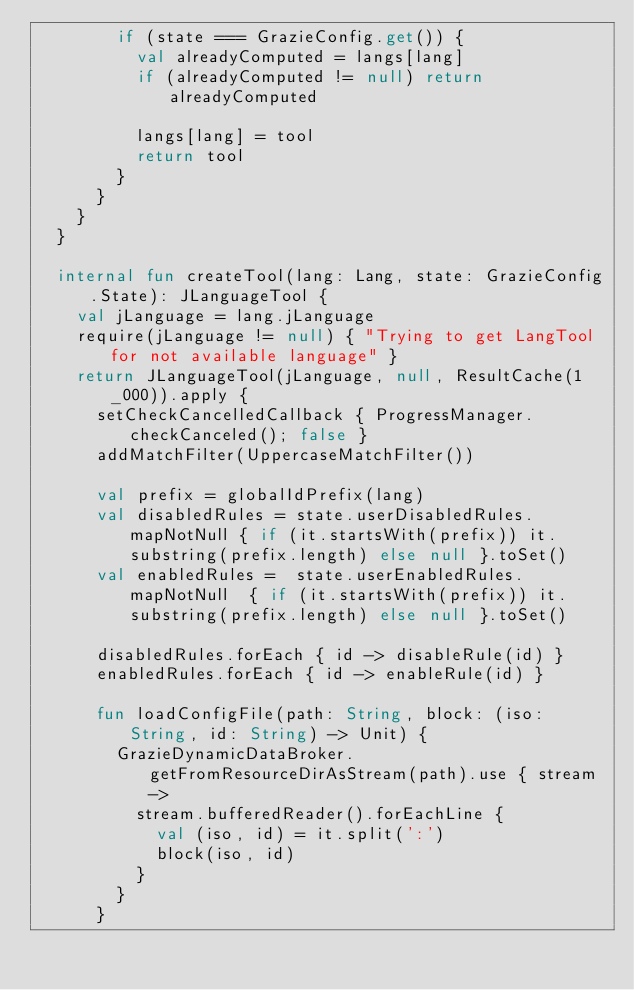Convert code to text. <code><loc_0><loc_0><loc_500><loc_500><_Kotlin_>        if (state === GrazieConfig.get()) {
          val alreadyComputed = langs[lang]
          if (alreadyComputed != null) return alreadyComputed

          langs[lang] = tool
          return tool
        }
      }
    }
  }

  internal fun createTool(lang: Lang, state: GrazieConfig.State): JLanguageTool {
    val jLanguage = lang.jLanguage
    require(jLanguage != null) { "Trying to get LangTool for not available language" }
    return JLanguageTool(jLanguage, null, ResultCache(1_000)).apply {
      setCheckCancelledCallback { ProgressManager.checkCanceled(); false }
      addMatchFilter(UppercaseMatchFilter())

      val prefix = globalIdPrefix(lang)
      val disabledRules = state.userDisabledRules.mapNotNull { if (it.startsWith(prefix)) it.substring(prefix.length) else null }.toSet()
      val enabledRules =  state.userEnabledRules.mapNotNull  { if (it.startsWith(prefix)) it.substring(prefix.length) else null }.toSet()

      disabledRules.forEach { id -> disableRule(id) }
      enabledRules.forEach { id -> enableRule(id) }

      fun loadConfigFile(path: String, block: (iso: String, id: String) -> Unit) {
        GrazieDynamicDataBroker.getFromResourceDirAsStream(path).use { stream ->
          stream.bufferedReader().forEachLine {
            val (iso, id) = it.split(':')
            block(iso, id)
          }
        }
      }
</code> 